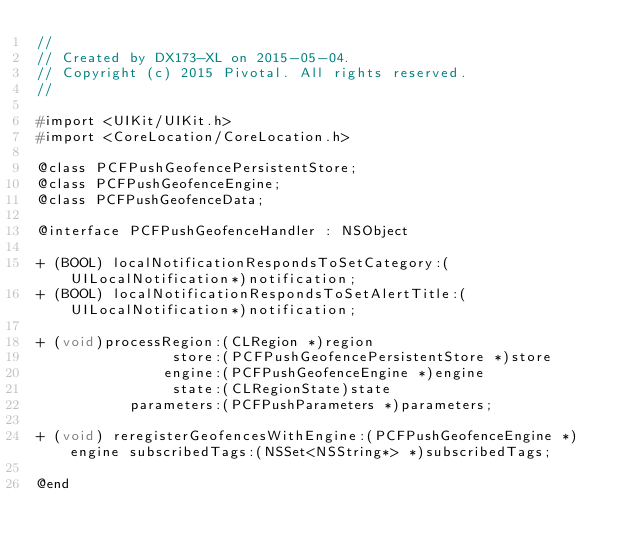Convert code to text. <code><loc_0><loc_0><loc_500><loc_500><_C_>//
// Created by DX173-XL on 2015-05-04.
// Copyright (c) 2015 Pivotal. All rights reserved.
//

#import <UIKit/UIKit.h>
#import <CoreLocation/CoreLocation.h>

@class PCFPushGeofencePersistentStore;
@class PCFPushGeofenceEngine;
@class PCFPushGeofenceData;

@interface PCFPushGeofenceHandler : NSObject

+ (BOOL) localNotificationRespondsToSetCategory:(UILocalNotification*)notification;
+ (BOOL) localNotificationRespondsToSetAlertTitle:(UILocalNotification*)notification;

+ (void)processRegion:(CLRegion *)region
                store:(PCFPushGeofencePersistentStore *)store
               engine:(PCFPushGeofenceEngine *)engine
                state:(CLRegionState)state
           parameters:(PCFPushParameters *)parameters;

+ (void) reregisterGeofencesWithEngine:(PCFPushGeofenceEngine *)engine subscribedTags:(NSSet<NSString*> *)subscribedTags;

@end
</code> 